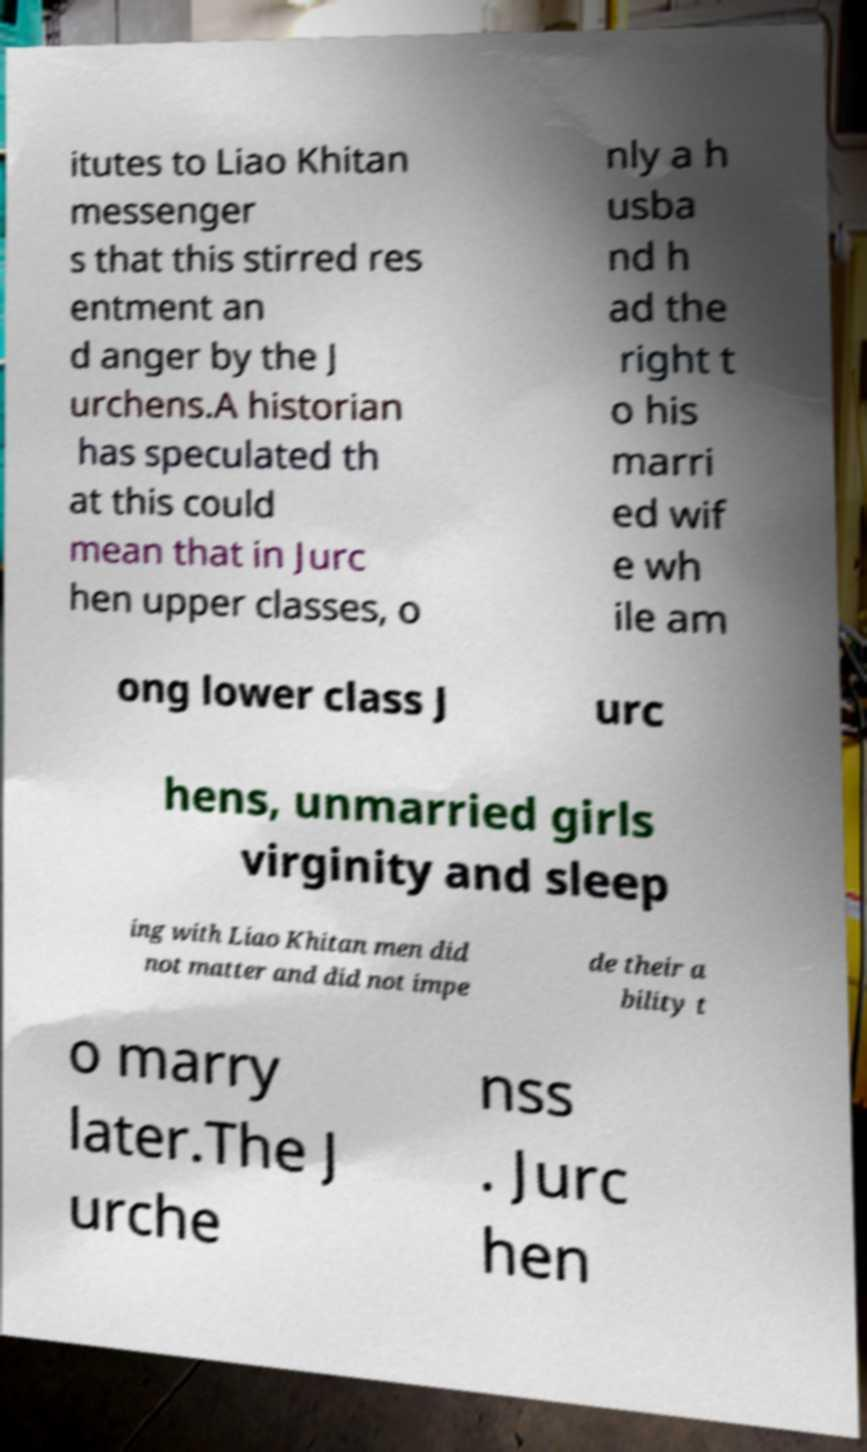Could you assist in decoding the text presented in this image and type it out clearly? itutes to Liao Khitan messenger s that this stirred res entment an d anger by the J urchens.A historian has speculated th at this could mean that in Jurc hen upper classes, o nly a h usba nd h ad the right t o his marri ed wif e wh ile am ong lower class J urc hens, unmarried girls virginity and sleep ing with Liao Khitan men did not matter and did not impe de their a bility t o marry later.The J urche nss . Jurc hen 